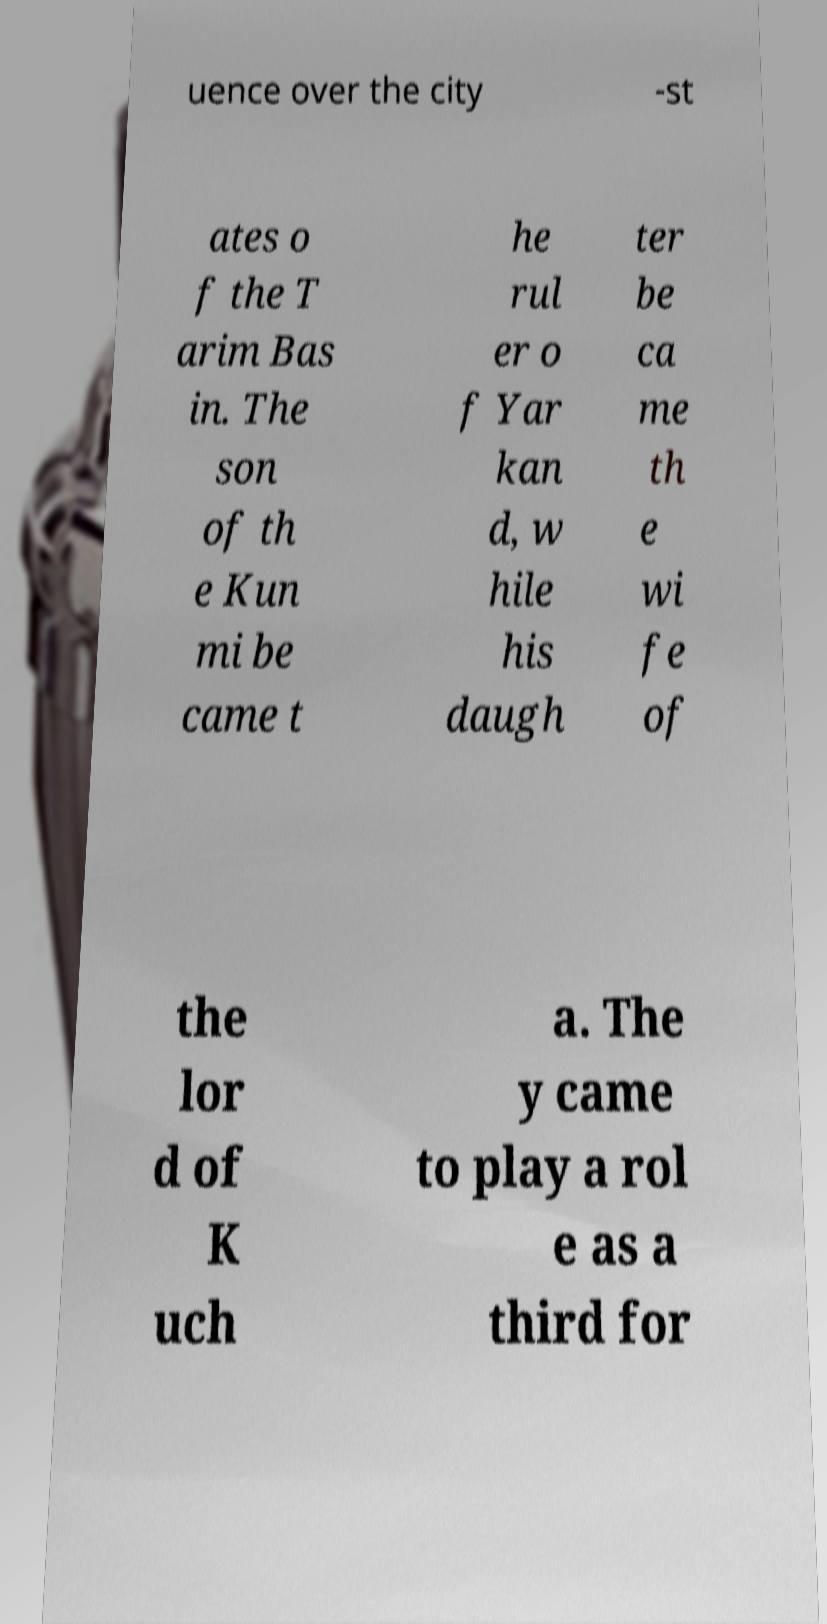Can you read and provide the text displayed in the image?This photo seems to have some interesting text. Can you extract and type it out for me? uence over the city -st ates o f the T arim Bas in. The son of th e Kun mi be came t he rul er o f Yar kan d, w hile his daugh ter be ca me th e wi fe of the lor d of K uch a. The y came to play a rol e as a third for 